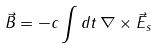Convert formula to latex. <formula><loc_0><loc_0><loc_500><loc_500>\vec { B } = - c \int { d t } \, \nabla \times \vec { E } _ { s }</formula> 